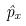<formula> <loc_0><loc_0><loc_500><loc_500>\hat { p } _ { x }</formula> 